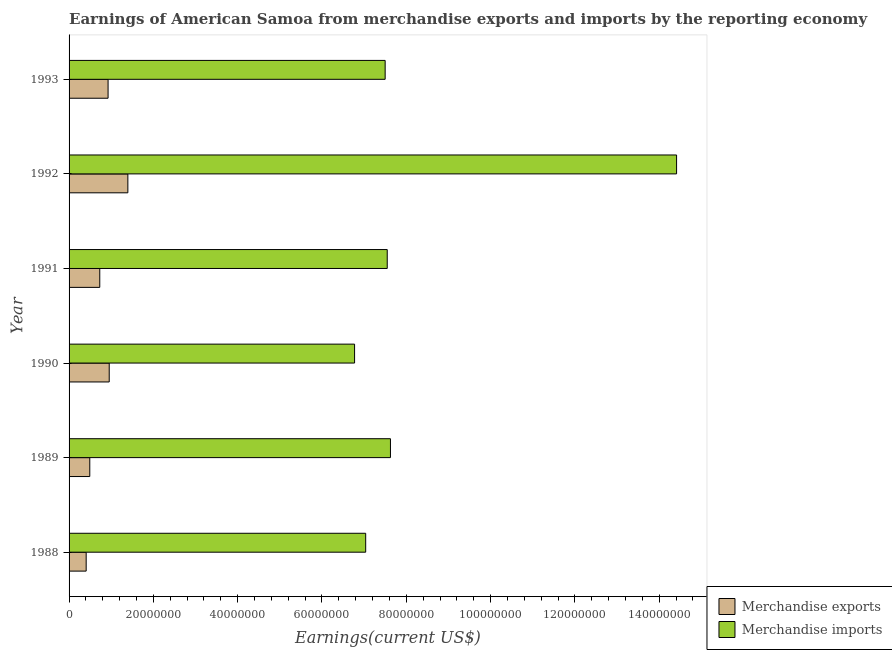How many different coloured bars are there?
Keep it short and to the point. 2. How many groups of bars are there?
Make the answer very short. 6. Are the number of bars per tick equal to the number of legend labels?
Your response must be concise. Yes. Are the number of bars on each tick of the Y-axis equal?
Ensure brevity in your answer.  Yes. What is the label of the 4th group of bars from the top?
Provide a succinct answer. 1990. In how many cases, is the number of bars for a given year not equal to the number of legend labels?
Keep it short and to the point. 0. What is the earnings from merchandise exports in 1989?
Give a very brief answer. 4.91e+06. Across all years, what is the maximum earnings from merchandise exports?
Your answer should be compact. 1.39e+07. Across all years, what is the minimum earnings from merchandise imports?
Your answer should be compact. 6.77e+07. In which year was the earnings from merchandise exports maximum?
Provide a succinct answer. 1992. What is the total earnings from merchandise imports in the graph?
Offer a terse response. 5.09e+08. What is the difference between the earnings from merchandise exports in 1990 and that in 1992?
Make the answer very short. -4.42e+06. What is the difference between the earnings from merchandise imports in 1989 and the earnings from merchandise exports in 1993?
Ensure brevity in your answer.  6.70e+07. What is the average earnings from merchandise exports per year?
Make the answer very short. 8.16e+06. In the year 1993, what is the difference between the earnings from merchandise imports and earnings from merchandise exports?
Your answer should be compact. 6.57e+07. What is the ratio of the earnings from merchandise imports in 1990 to that in 1991?
Provide a succinct answer. 0.9. Is the earnings from merchandise exports in 1988 less than that in 1989?
Make the answer very short. Yes. What is the difference between the highest and the second highest earnings from merchandise exports?
Ensure brevity in your answer.  4.42e+06. What is the difference between the highest and the lowest earnings from merchandise exports?
Offer a very short reply. 9.89e+06. In how many years, is the earnings from merchandise imports greater than the average earnings from merchandise imports taken over all years?
Keep it short and to the point. 1. What does the 1st bar from the top in 1988 represents?
Keep it short and to the point. Merchandise imports. What does the 2nd bar from the bottom in 1990 represents?
Your answer should be very brief. Merchandise imports. Are all the bars in the graph horizontal?
Keep it short and to the point. Yes. How many years are there in the graph?
Your answer should be compact. 6. What is the difference between two consecutive major ticks on the X-axis?
Provide a succinct answer. 2.00e+07. Are the values on the major ticks of X-axis written in scientific E-notation?
Your response must be concise. No. Does the graph contain any zero values?
Your answer should be compact. No. Where does the legend appear in the graph?
Keep it short and to the point. Bottom right. How many legend labels are there?
Your response must be concise. 2. What is the title of the graph?
Provide a short and direct response. Earnings of American Samoa from merchandise exports and imports by the reporting economy. Does "GDP at market prices" appear as one of the legend labels in the graph?
Provide a succinct answer. No. What is the label or title of the X-axis?
Give a very brief answer. Earnings(current US$). What is the Earnings(current US$) of Merchandise exports in 1988?
Give a very brief answer. 4.06e+06. What is the Earnings(current US$) in Merchandise imports in 1988?
Your answer should be very brief. 7.04e+07. What is the Earnings(current US$) of Merchandise exports in 1989?
Ensure brevity in your answer.  4.91e+06. What is the Earnings(current US$) in Merchandise imports in 1989?
Offer a terse response. 7.62e+07. What is the Earnings(current US$) of Merchandise exports in 1990?
Your answer should be compact. 9.52e+06. What is the Earnings(current US$) in Merchandise imports in 1990?
Keep it short and to the point. 6.77e+07. What is the Earnings(current US$) of Merchandise exports in 1991?
Provide a succinct answer. 7.28e+06. What is the Earnings(current US$) of Merchandise imports in 1991?
Give a very brief answer. 7.55e+07. What is the Earnings(current US$) of Merchandise exports in 1992?
Offer a terse response. 1.39e+07. What is the Earnings(current US$) of Merchandise imports in 1992?
Your answer should be very brief. 1.44e+08. What is the Earnings(current US$) in Merchandise exports in 1993?
Make the answer very short. 9.25e+06. What is the Earnings(current US$) of Merchandise imports in 1993?
Offer a very short reply. 7.50e+07. Across all years, what is the maximum Earnings(current US$) in Merchandise exports?
Give a very brief answer. 1.39e+07. Across all years, what is the maximum Earnings(current US$) in Merchandise imports?
Ensure brevity in your answer.  1.44e+08. Across all years, what is the minimum Earnings(current US$) in Merchandise exports?
Make the answer very short. 4.06e+06. Across all years, what is the minimum Earnings(current US$) in Merchandise imports?
Give a very brief answer. 6.77e+07. What is the total Earnings(current US$) in Merchandise exports in the graph?
Make the answer very short. 4.90e+07. What is the total Earnings(current US$) of Merchandise imports in the graph?
Your answer should be compact. 5.09e+08. What is the difference between the Earnings(current US$) in Merchandise exports in 1988 and that in 1989?
Provide a short and direct response. -8.56e+05. What is the difference between the Earnings(current US$) in Merchandise imports in 1988 and that in 1989?
Give a very brief answer. -5.88e+06. What is the difference between the Earnings(current US$) of Merchandise exports in 1988 and that in 1990?
Offer a terse response. -5.47e+06. What is the difference between the Earnings(current US$) of Merchandise imports in 1988 and that in 1990?
Your response must be concise. 2.64e+06. What is the difference between the Earnings(current US$) in Merchandise exports in 1988 and that in 1991?
Make the answer very short. -3.22e+06. What is the difference between the Earnings(current US$) in Merchandise imports in 1988 and that in 1991?
Provide a short and direct response. -5.11e+06. What is the difference between the Earnings(current US$) of Merchandise exports in 1988 and that in 1992?
Ensure brevity in your answer.  -9.89e+06. What is the difference between the Earnings(current US$) in Merchandise imports in 1988 and that in 1992?
Provide a short and direct response. -7.38e+07. What is the difference between the Earnings(current US$) in Merchandise exports in 1988 and that in 1993?
Give a very brief answer. -5.20e+06. What is the difference between the Earnings(current US$) in Merchandise imports in 1988 and that in 1993?
Provide a short and direct response. -4.62e+06. What is the difference between the Earnings(current US$) of Merchandise exports in 1989 and that in 1990?
Provide a succinct answer. -4.61e+06. What is the difference between the Earnings(current US$) of Merchandise imports in 1989 and that in 1990?
Your answer should be compact. 8.51e+06. What is the difference between the Earnings(current US$) in Merchandise exports in 1989 and that in 1991?
Provide a succinct answer. -2.37e+06. What is the difference between the Earnings(current US$) of Merchandise imports in 1989 and that in 1991?
Offer a very short reply. 7.65e+05. What is the difference between the Earnings(current US$) in Merchandise exports in 1989 and that in 1992?
Offer a very short reply. -9.03e+06. What is the difference between the Earnings(current US$) in Merchandise imports in 1989 and that in 1992?
Make the answer very short. -6.79e+07. What is the difference between the Earnings(current US$) in Merchandise exports in 1989 and that in 1993?
Your response must be concise. -4.34e+06. What is the difference between the Earnings(current US$) in Merchandise imports in 1989 and that in 1993?
Provide a succinct answer. 1.26e+06. What is the difference between the Earnings(current US$) in Merchandise exports in 1990 and that in 1991?
Your response must be concise. 2.24e+06. What is the difference between the Earnings(current US$) in Merchandise imports in 1990 and that in 1991?
Ensure brevity in your answer.  -7.75e+06. What is the difference between the Earnings(current US$) in Merchandise exports in 1990 and that in 1992?
Ensure brevity in your answer.  -4.42e+06. What is the difference between the Earnings(current US$) of Merchandise imports in 1990 and that in 1992?
Offer a terse response. -7.64e+07. What is the difference between the Earnings(current US$) in Merchandise exports in 1990 and that in 1993?
Your answer should be very brief. 2.68e+05. What is the difference between the Earnings(current US$) in Merchandise imports in 1990 and that in 1993?
Your answer should be compact. -7.25e+06. What is the difference between the Earnings(current US$) in Merchandise exports in 1991 and that in 1992?
Your answer should be compact. -6.66e+06. What is the difference between the Earnings(current US$) in Merchandise imports in 1991 and that in 1992?
Provide a succinct answer. -6.86e+07. What is the difference between the Earnings(current US$) of Merchandise exports in 1991 and that in 1993?
Provide a short and direct response. -1.97e+06. What is the difference between the Earnings(current US$) of Merchandise imports in 1991 and that in 1993?
Offer a terse response. 4.96e+05. What is the difference between the Earnings(current US$) in Merchandise exports in 1992 and that in 1993?
Your answer should be very brief. 4.69e+06. What is the difference between the Earnings(current US$) in Merchandise imports in 1992 and that in 1993?
Provide a short and direct response. 6.91e+07. What is the difference between the Earnings(current US$) in Merchandise exports in 1988 and the Earnings(current US$) in Merchandise imports in 1989?
Offer a very short reply. -7.22e+07. What is the difference between the Earnings(current US$) in Merchandise exports in 1988 and the Earnings(current US$) in Merchandise imports in 1990?
Give a very brief answer. -6.37e+07. What is the difference between the Earnings(current US$) in Merchandise exports in 1988 and the Earnings(current US$) in Merchandise imports in 1991?
Give a very brief answer. -7.14e+07. What is the difference between the Earnings(current US$) of Merchandise exports in 1988 and the Earnings(current US$) of Merchandise imports in 1992?
Offer a very short reply. -1.40e+08. What is the difference between the Earnings(current US$) in Merchandise exports in 1988 and the Earnings(current US$) in Merchandise imports in 1993?
Keep it short and to the point. -7.09e+07. What is the difference between the Earnings(current US$) in Merchandise exports in 1989 and the Earnings(current US$) in Merchandise imports in 1990?
Ensure brevity in your answer.  -6.28e+07. What is the difference between the Earnings(current US$) in Merchandise exports in 1989 and the Earnings(current US$) in Merchandise imports in 1991?
Your answer should be compact. -7.06e+07. What is the difference between the Earnings(current US$) in Merchandise exports in 1989 and the Earnings(current US$) in Merchandise imports in 1992?
Ensure brevity in your answer.  -1.39e+08. What is the difference between the Earnings(current US$) in Merchandise exports in 1989 and the Earnings(current US$) in Merchandise imports in 1993?
Your answer should be compact. -7.01e+07. What is the difference between the Earnings(current US$) in Merchandise exports in 1990 and the Earnings(current US$) in Merchandise imports in 1991?
Your response must be concise. -6.60e+07. What is the difference between the Earnings(current US$) in Merchandise exports in 1990 and the Earnings(current US$) in Merchandise imports in 1992?
Give a very brief answer. -1.35e+08. What is the difference between the Earnings(current US$) of Merchandise exports in 1990 and the Earnings(current US$) of Merchandise imports in 1993?
Your answer should be very brief. -6.55e+07. What is the difference between the Earnings(current US$) in Merchandise exports in 1991 and the Earnings(current US$) in Merchandise imports in 1992?
Your response must be concise. -1.37e+08. What is the difference between the Earnings(current US$) in Merchandise exports in 1991 and the Earnings(current US$) in Merchandise imports in 1993?
Offer a terse response. -6.77e+07. What is the difference between the Earnings(current US$) of Merchandise exports in 1992 and the Earnings(current US$) of Merchandise imports in 1993?
Your answer should be compact. -6.10e+07. What is the average Earnings(current US$) in Merchandise exports per year?
Offer a terse response. 8.16e+06. What is the average Earnings(current US$) in Merchandise imports per year?
Offer a terse response. 8.48e+07. In the year 1988, what is the difference between the Earnings(current US$) in Merchandise exports and Earnings(current US$) in Merchandise imports?
Make the answer very short. -6.63e+07. In the year 1989, what is the difference between the Earnings(current US$) in Merchandise exports and Earnings(current US$) in Merchandise imports?
Your response must be concise. -7.13e+07. In the year 1990, what is the difference between the Earnings(current US$) in Merchandise exports and Earnings(current US$) in Merchandise imports?
Provide a short and direct response. -5.82e+07. In the year 1991, what is the difference between the Earnings(current US$) in Merchandise exports and Earnings(current US$) in Merchandise imports?
Offer a terse response. -6.82e+07. In the year 1992, what is the difference between the Earnings(current US$) in Merchandise exports and Earnings(current US$) in Merchandise imports?
Ensure brevity in your answer.  -1.30e+08. In the year 1993, what is the difference between the Earnings(current US$) in Merchandise exports and Earnings(current US$) in Merchandise imports?
Offer a terse response. -6.57e+07. What is the ratio of the Earnings(current US$) in Merchandise exports in 1988 to that in 1989?
Offer a very short reply. 0.83. What is the ratio of the Earnings(current US$) of Merchandise imports in 1988 to that in 1989?
Make the answer very short. 0.92. What is the ratio of the Earnings(current US$) of Merchandise exports in 1988 to that in 1990?
Keep it short and to the point. 0.43. What is the ratio of the Earnings(current US$) of Merchandise imports in 1988 to that in 1990?
Offer a terse response. 1.04. What is the ratio of the Earnings(current US$) of Merchandise exports in 1988 to that in 1991?
Make the answer very short. 0.56. What is the ratio of the Earnings(current US$) of Merchandise imports in 1988 to that in 1991?
Offer a terse response. 0.93. What is the ratio of the Earnings(current US$) in Merchandise exports in 1988 to that in 1992?
Offer a terse response. 0.29. What is the ratio of the Earnings(current US$) of Merchandise imports in 1988 to that in 1992?
Your response must be concise. 0.49. What is the ratio of the Earnings(current US$) in Merchandise exports in 1988 to that in 1993?
Provide a short and direct response. 0.44. What is the ratio of the Earnings(current US$) in Merchandise imports in 1988 to that in 1993?
Ensure brevity in your answer.  0.94. What is the ratio of the Earnings(current US$) of Merchandise exports in 1989 to that in 1990?
Your response must be concise. 0.52. What is the ratio of the Earnings(current US$) in Merchandise imports in 1989 to that in 1990?
Give a very brief answer. 1.13. What is the ratio of the Earnings(current US$) in Merchandise exports in 1989 to that in 1991?
Keep it short and to the point. 0.67. What is the ratio of the Earnings(current US$) in Merchandise imports in 1989 to that in 1991?
Your answer should be compact. 1.01. What is the ratio of the Earnings(current US$) of Merchandise exports in 1989 to that in 1992?
Provide a succinct answer. 0.35. What is the ratio of the Earnings(current US$) in Merchandise imports in 1989 to that in 1992?
Your answer should be very brief. 0.53. What is the ratio of the Earnings(current US$) in Merchandise exports in 1989 to that in 1993?
Ensure brevity in your answer.  0.53. What is the ratio of the Earnings(current US$) in Merchandise imports in 1989 to that in 1993?
Ensure brevity in your answer.  1.02. What is the ratio of the Earnings(current US$) in Merchandise exports in 1990 to that in 1991?
Provide a succinct answer. 1.31. What is the ratio of the Earnings(current US$) of Merchandise imports in 1990 to that in 1991?
Provide a succinct answer. 0.9. What is the ratio of the Earnings(current US$) in Merchandise exports in 1990 to that in 1992?
Offer a terse response. 0.68. What is the ratio of the Earnings(current US$) in Merchandise imports in 1990 to that in 1992?
Provide a short and direct response. 0.47. What is the ratio of the Earnings(current US$) in Merchandise imports in 1990 to that in 1993?
Give a very brief answer. 0.9. What is the ratio of the Earnings(current US$) of Merchandise exports in 1991 to that in 1992?
Provide a short and direct response. 0.52. What is the ratio of the Earnings(current US$) in Merchandise imports in 1991 to that in 1992?
Your answer should be compact. 0.52. What is the ratio of the Earnings(current US$) in Merchandise exports in 1991 to that in 1993?
Provide a short and direct response. 0.79. What is the ratio of the Earnings(current US$) in Merchandise imports in 1991 to that in 1993?
Provide a short and direct response. 1.01. What is the ratio of the Earnings(current US$) in Merchandise exports in 1992 to that in 1993?
Provide a succinct answer. 1.51. What is the ratio of the Earnings(current US$) of Merchandise imports in 1992 to that in 1993?
Offer a terse response. 1.92. What is the difference between the highest and the second highest Earnings(current US$) in Merchandise exports?
Your answer should be compact. 4.42e+06. What is the difference between the highest and the second highest Earnings(current US$) in Merchandise imports?
Provide a succinct answer. 6.79e+07. What is the difference between the highest and the lowest Earnings(current US$) in Merchandise exports?
Provide a short and direct response. 9.89e+06. What is the difference between the highest and the lowest Earnings(current US$) in Merchandise imports?
Offer a terse response. 7.64e+07. 